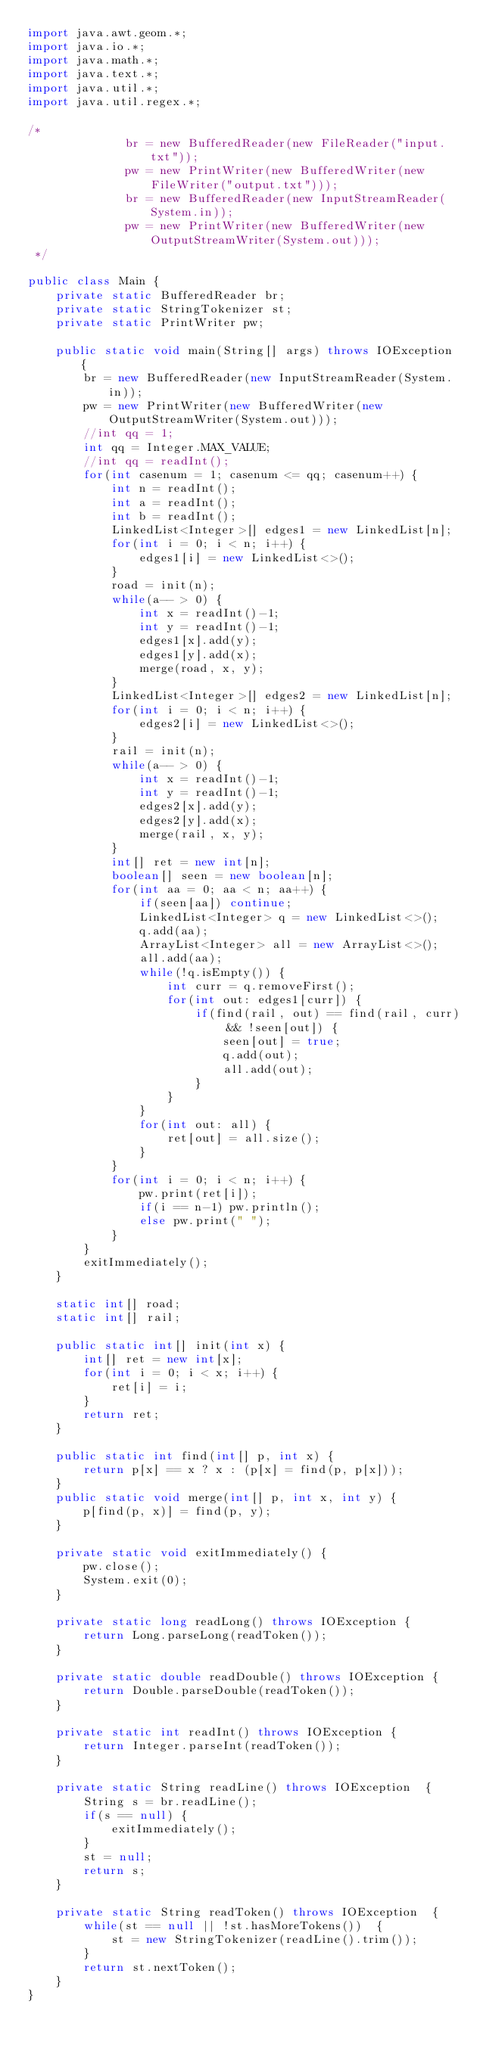<code> <loc_0><loc_0><loc_500><loc_500><_Java_>import java.awt.geom.*;
import java.io.*;
import java.math.*;
import java.text.*; 
import java.util.*;
import java.util.regex.*;

/*
			  br = new BufferedReader(new FileReader("input.txt"));
			  pw = new PrintWriter(new BufferedWriter(new FileWriter("output.txt")));
			  br = new BufferedReader(new InputStreamReader(System.in));
			  pw = new PrintWriter(new BufferedWriter(new OutputStreamWriter(System.out)));
 */

public class Main {
	private static BufferedReader br;
	private static StringTokenizer st;
	private static PrintWriter pw;

	public static void main(String[] args) throws IOException {
		br = new BufferedReader(new InputStreamReader(System.in));
		pw = new PrintWriter(new BufferedWriter(new OutputStreamWriter(System.out)));
		//int qq = 1;
		int qq = Integer.MAX_VALUE;
		//int qq = readInt();
		for(int casenum = 1; casenum <= qq; casenum++) {
			int n = readInt();
			int a = readInt();
			int b = readInt();
			LinkedList<Integer>[] edges1 = new LinkedList[n];
			for(int i = 0; i < n; i++) {
				edges1[i] = new LinkedList<>();
			}
			road = init(n);
			while(a-- > 0) {
				int x = readInt()-1;
				int y = readInt()-1;
				edges1[x].add(y);
				edges1[y].add(x);
				merge(road, x, y);
			}
			LinkedList<Integer>[] edges2 = new LinkedList[n];
			for(int i = 0; i < n; i++) {
				edges2[i] = new LinkedList<>();
			}
			rail = init(n);
			while(a-- > 0) {
				int x = readInt()-1;
				int y = readInt()-1;
				edges2[x].add(y);
				edges2[y].add(x);
				merge(rail, x, y);
			}
			int[] ret = new int[n];
			boolean[] seen = new boolean[n];
			for(int aa = 0; aa < n; aa++) {
				if(seen[aa]) continue;
				LinkedList<Integer> q = new LinkedList<>();
				q.add(aa);
				ArrayList<Integer> all = new ArrayList<>();
				all.add(aa);
				while(!q.isEmpty()) {
					int curr = q.removeFirst();
					for(int out: edges1[curr]) {
						if(find(rail, out) == find(rail, curr) && !seen[out]) {
							seen[out] = true;
							q.add(out);
							all.add(out);
						}
					}
				}
				for(int out: all) {
					ret[out] = all.size();
				}
			}
			for(int i = 0; i < n; i++) {
				pw.print(ret[i]);
				if(i == n-1) pw.println();
				else pw.print(" ");
			}
		}
		exitImmediately();
	}

	static int[] road;
	static int[] rail;

	public static int[] init(int x) {
		int[] ret = new int[x];
		for(int i = 0; i < x; i++) {
			ret[i] = i;
		}
		return ret;
	}

	public static int find(int[] p, int x) {
		return p[x] == x ? x : (p[x] = find(p, p[x]));
	}
	public static void merge(int[] p, int x, int y) {
		p[find(p, x)] = find(p, y);
	}

	private static void exitImmediately() {
		pw.close();
		System.exit(0);
	}

	private static long readLong() throws IOException {
		return Long.parseLong(readToken());
	}

	private static double readDouble() throws IOException {
		return Double.parseDouble(readToken());
	}

	private static int readInt() throws IOException {
		return Integer.parseInt(readToken());
	}

	private static String readLine() throws IOException  {
		String s = br.readLine();
		if(s == null) {
			exitImmediately();
		}
		st = null;
		return s;
	}

	private static String readToken() throws IOException  {
		while(st == null || !st.hasMoreTokens())  {
			st = new StringTokenizer(readLine().trim());
		}
		return st.nextToken();
	}
}</code> 